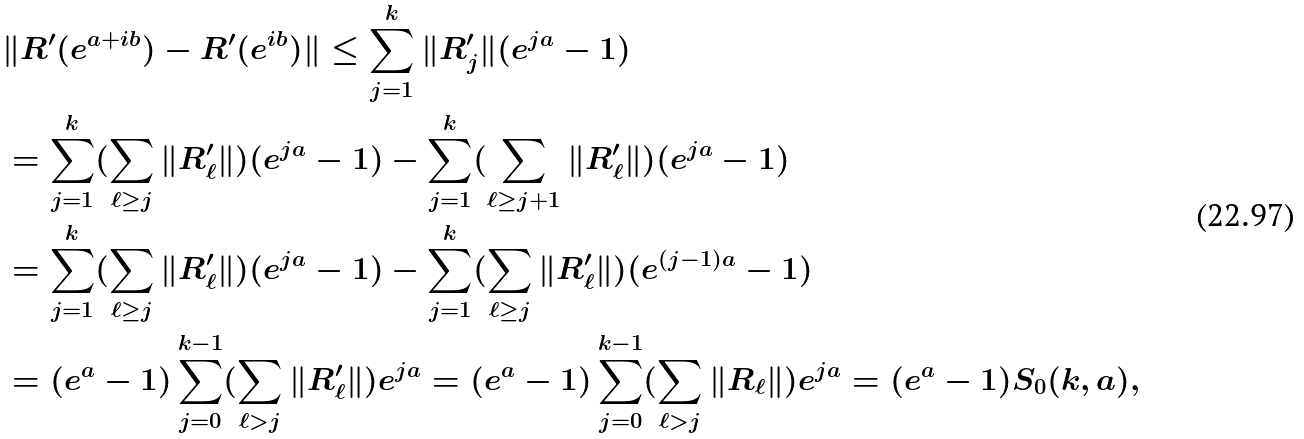Convert formula to latex. <formula><loc_0><loc_0><loc_500><loc_500>& \| R ^ { \prime } ( e ^ { a + i b } ) - R ^ { \prime } ( e ^ { i b } ) \| \leq \sum _ { j = 1 } ^ { k } \| R ^ { \prime } _ { j } \| ( e ^ { j a } - 1 ) \\ & = \sum _ { j = 1 } ^ { k } ( \sum _ { \ell \geq j } \| R ^ { \prime } _ { \ell } \| ) ( e ^ { j a } - 1 ) - \sum _ { j = 1 } ^ { k } ( \sum _ { \ell \geq j + 1 } \| R ^ { \prime } _ { \ell } \| ) ( e ^ { j a } - 1 ) \\ & = \sum _ { j = 1 } ^ { k } ( \sum _ { \ell \geq j } \| R ^ { \prime } _ { \ell } \| ) ( e ^ { j a } - 1 ) - \sum _ { j = 1 } ^ { k } ( \sum _ { \ell \geq j } \| R ^ { \prime } _ { \ell } \| ) ( e ^ { ( j - 1 ) a } - 1 ) \\ & = ( e ^ { a } - 1 ) \sum _ { j = 0 } ^ { k - 1 } ( \sum _ { \ell > j } \| R ^ { \prime } _ { \ell } \| ) e ^ { j a } = ( e ^ { a } - 1 ) \sum _ { j = 0 } ^ { k - 1 } ( \sum _ { \ell > j } \| R _ { \ell } \| ) e ^ { j a } = ( e ^ { a } - 1 ) S _ { 0 } ( k , a ) ,</formula> 